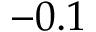Convert formula to latex. <formula><loc_0><loc_0><loc_500><loc_500>- 0 . 1</formula> 